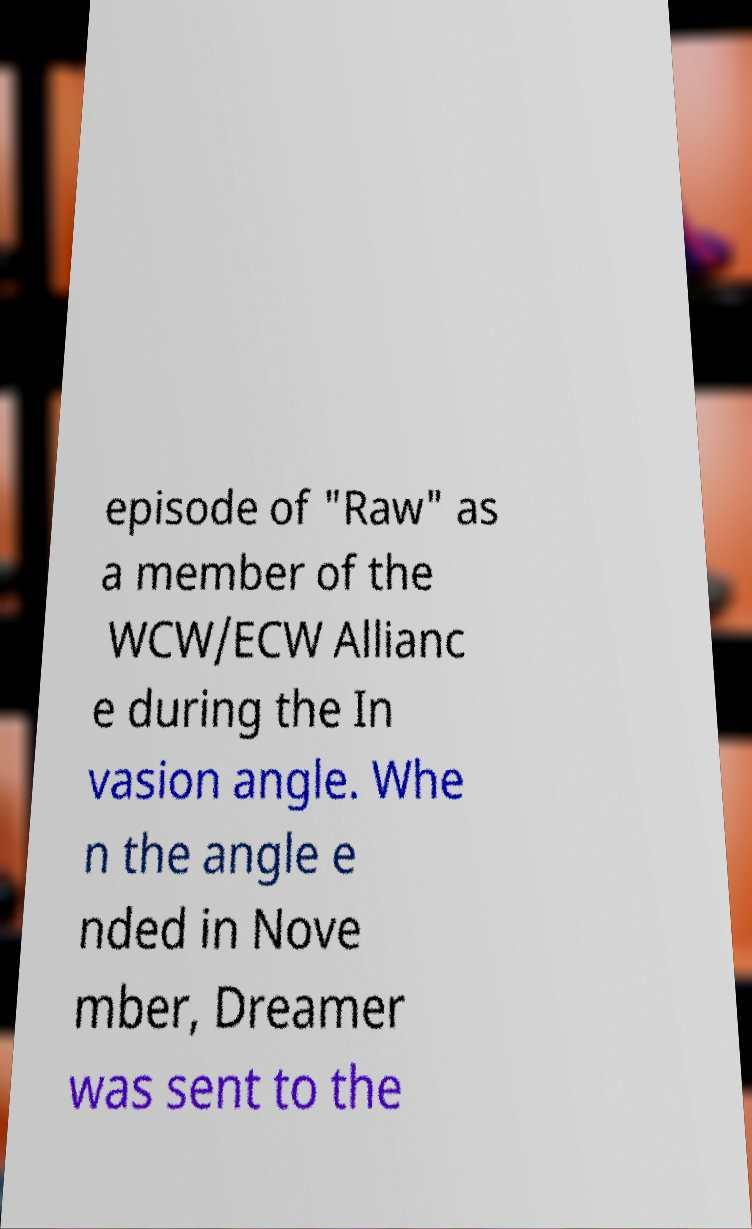Can you accurately transcribe the text from the provided image for me? episode of "Raw" as a member of the WCW/ECW Allianc e during the In vasion angle. Whe n the angle e nded in Nove mber, Dreamer was sent to the 